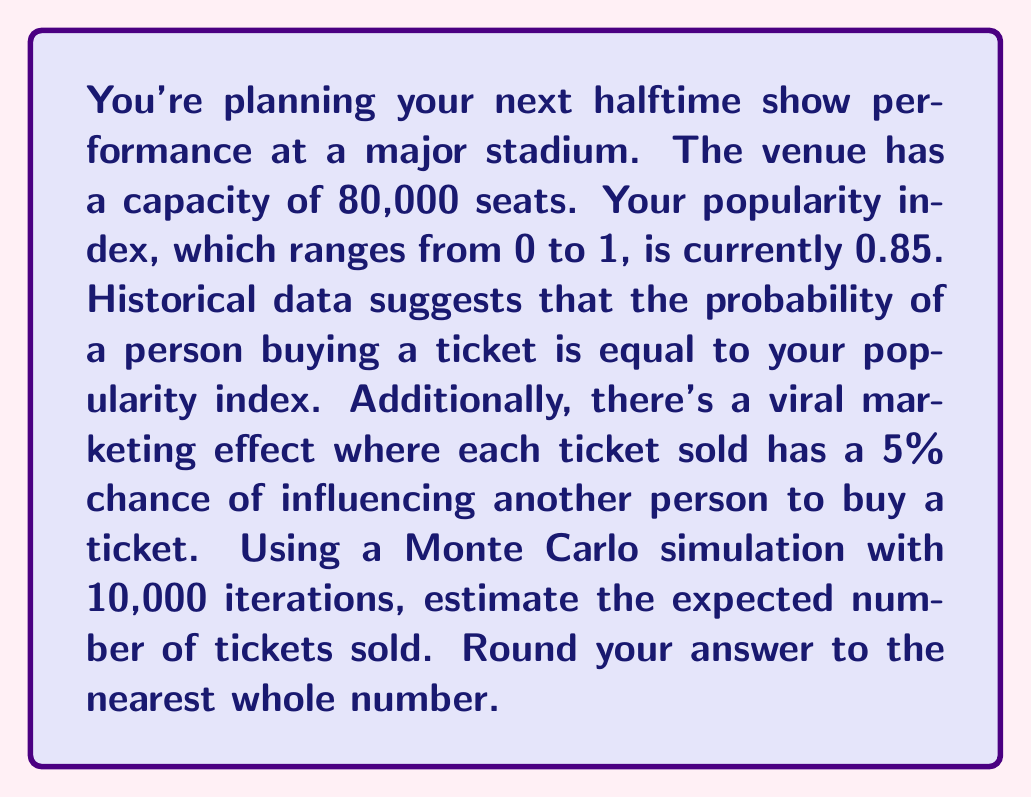What is the answer to this math problem? To solve this problem, we need to use a Monte Carlo simulation. Here's the step-by-step process:

1) Initialize variables:
   - Venue capacity: $N = 80,000$
   - Popularity index: $p = 0.85$
   - Viral marketing effect: $v = 0.05$
   - Number of iterations: $M = 10,000$

2) For each iteration:
   a) Initialize ticket sales: $S = 0$
   b) For each potential attendee (1 to N):
      - Generate a random number $r_1 \sim U(0,1)$
      - If $r_1 \leq p$, increment $S$ by 1
   c) Account for viral marketing:
      - For each ticket sold:
        - Generate a random number $r_2 \sim U(0,1)$
        - If $r_2 \leq v$ and $S < N$, increment $S$ by 1

3) Calculate the average ticket sales across all iterations:

   $$E[S] = \frac{1}{M} \sum_{i=1}^M S_i$$

   where $S_i$ is the number of tickets sold in the $i$-th iteration.

4) Round the result to the nearest whole number.

Here's a Python code snippet to implement this simulation:

```python
import numpy as np

N, p, v, M = 80000, 0.85, 0.05, 10000
results = []

for _ in range(M):
    S = np.sum(np.random.random(N) <= p)
    viral = np.sum(np.random.random(S) <= v)
    S = min(N, S + viral)
    results.append(S)

expected_sales = round(np.mean(results))
```

The simulation accounts for both the initial probability of ticket purchase based on popularity and the viral marketing effect. The expected number of tickets sold is the average of all simulation iterations, rounded to the nearest whole number.
Answer: 68,915 